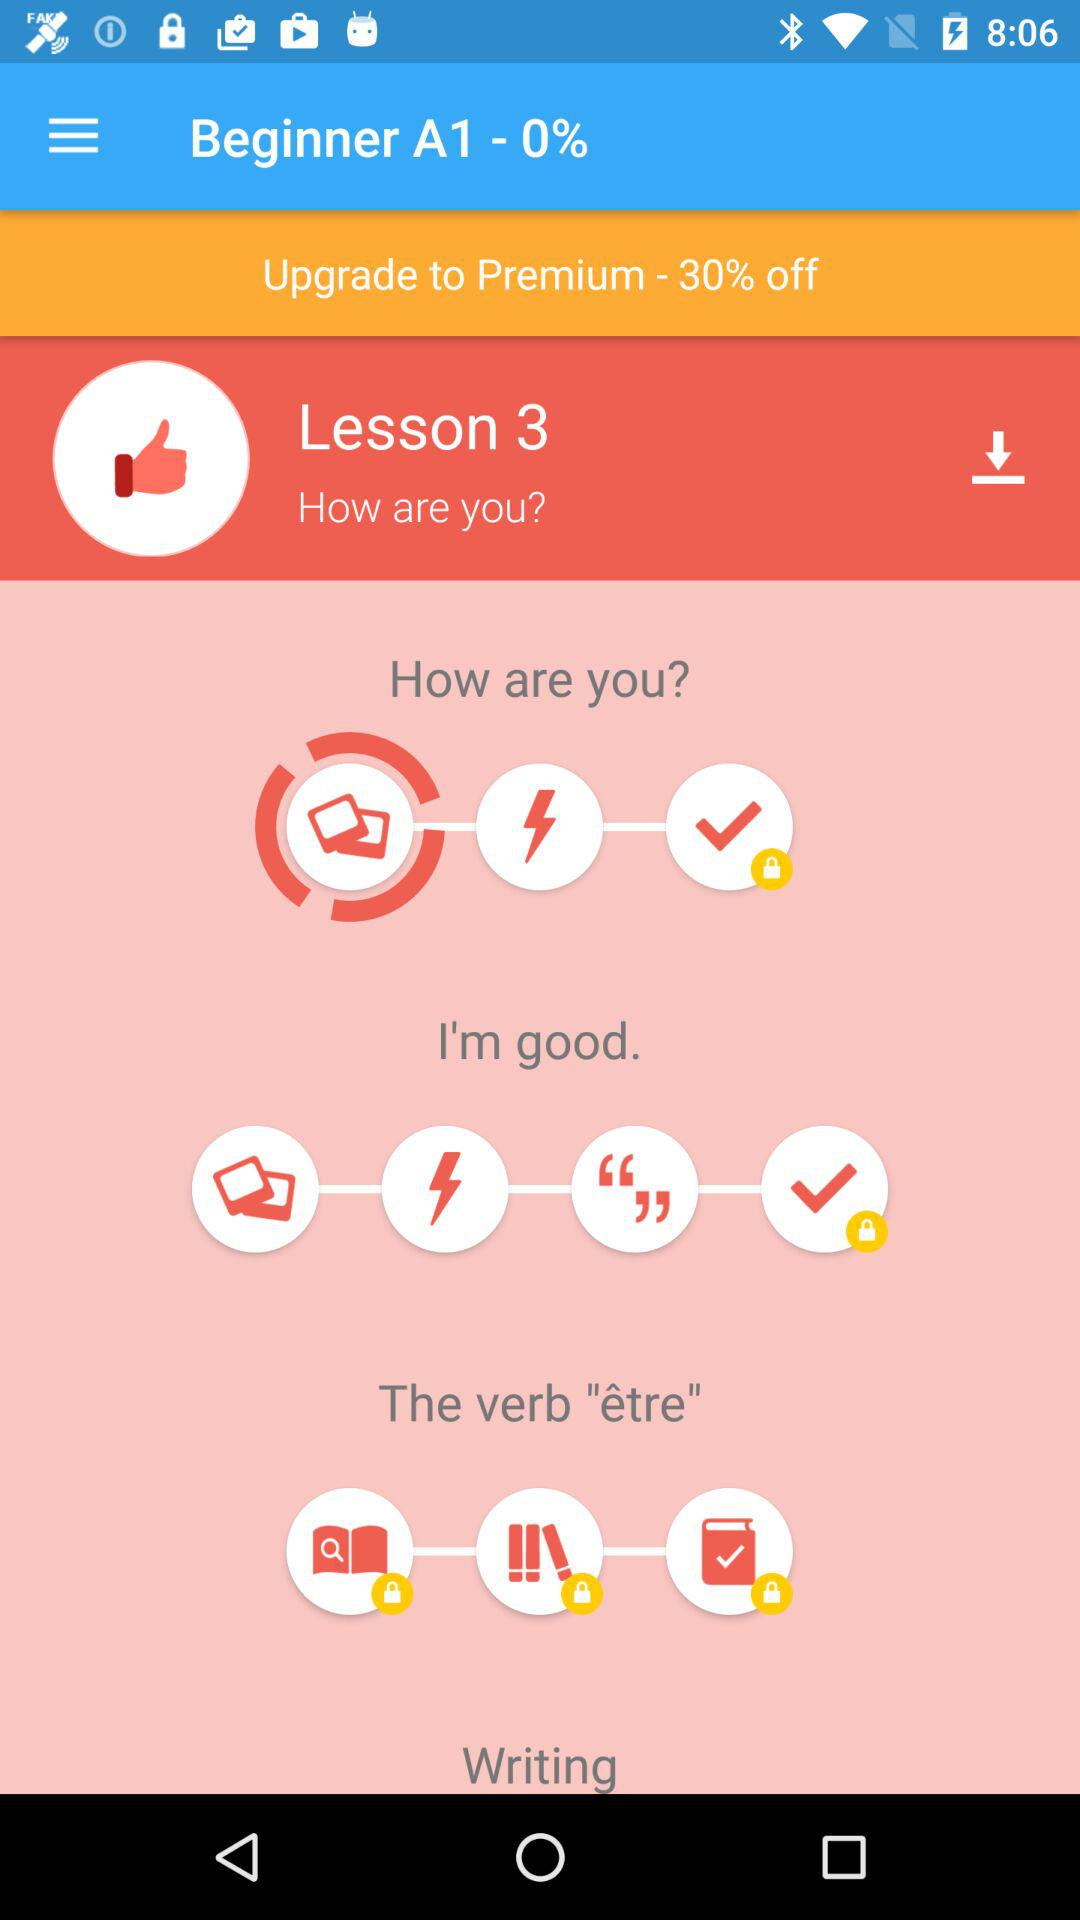Is this a free lesson, or do I need to unlock it? Lesson 3 appears to be readily accessible and possibly free, as there is no locked icon on it, unlike other activities indicated by the padlocks. To access the entire content, however, you might have to upgrade to the premium version, as suggested by the 'Upgrade to Premium - 30% off' banner visible at the top of the image. 